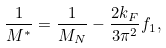Convert formula to latex. <formula><loc_0><loc_0><loc_500><loc_500>\frac { 1 } { M ^ { * } } = \frac { 1 } { M _ { N } } - \frac { 2 k _ { F } } { 3 \pi ^ { 2 } } f _ { 1 } ,</formula> 